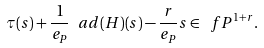<formula> <loc_0><loc_0><loc_500><loc_500>\tau ( s ) + \frac { 1 } { e _ { P } } \ a d ( H ) ( s ) - \frac { r } { e _ { P } } s \in \ f P ^ { 1 + r } .</formula> 